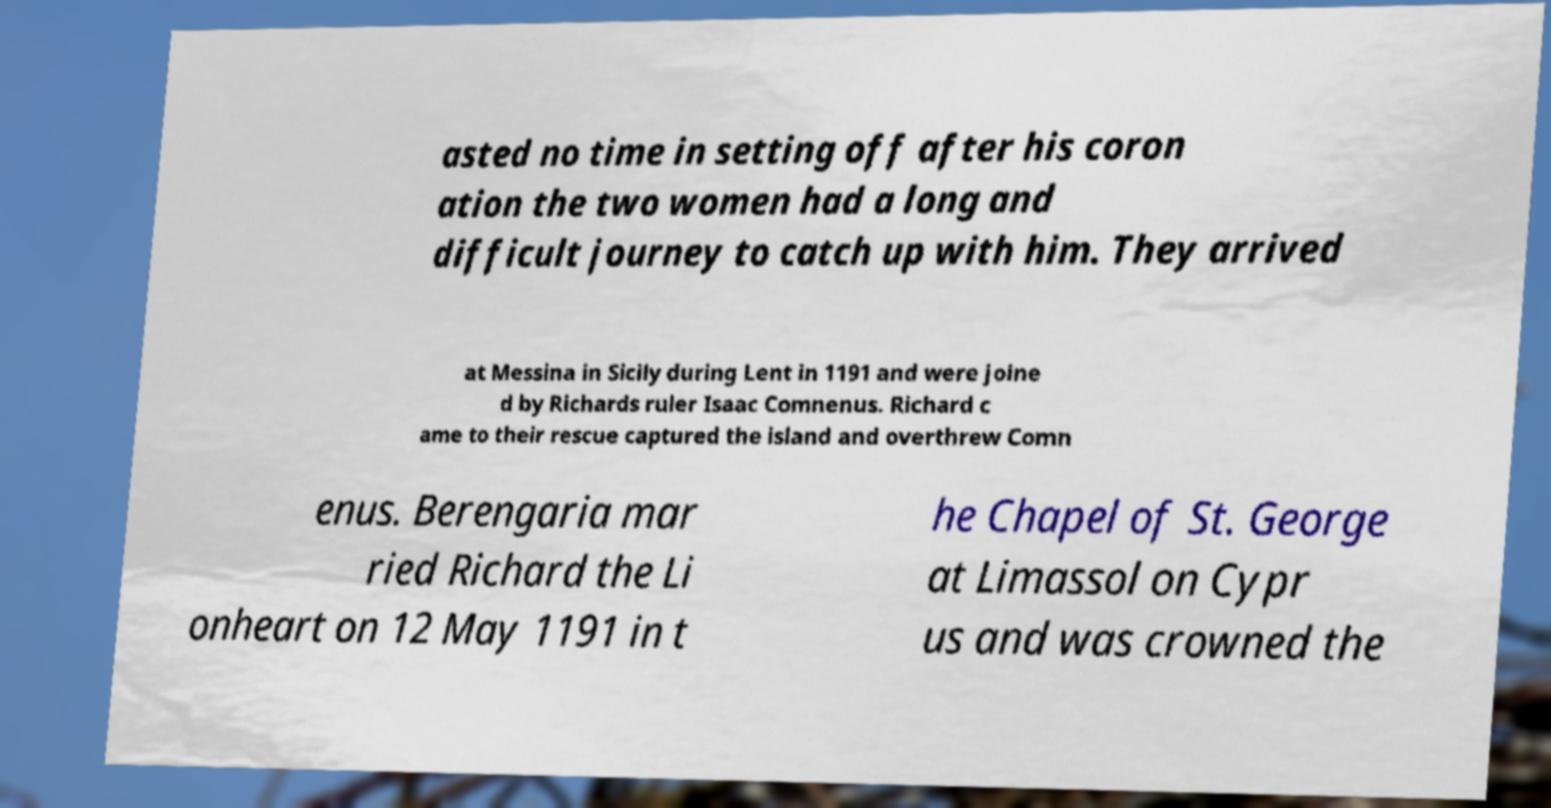Could you assist in decoding the text presented in this image and type it out clearly? asted no time in setting off after his coron ation the two women had a long and difficult journey to catch up with him. They arrived at Messina in Sicily during Lent in 1191 and were joine d by Richards ruler Isaac Comnenus. Richard c ame to their rescue captured the island and overthrew Comn enus. Berengaria mar ried Richard the Li onheart on 12 May 1191 in t he Chapel of St. George at Limassol on Cypr us and was crowned the 